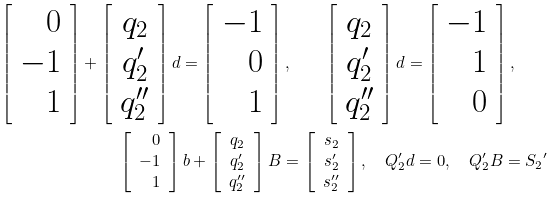Convert formula to latex. <formula><loc_0><loc_0><loc_500><loc_500>\left [ \begin{array} { r } 0 \\ - 1 \\ 1 \end{array} \right ] + \left [ \begin{array} { c } q _ { 2 } \\ q _ { 2 } ^ { \prime } \\ q _ { 2 } ^ { \prime \prime } \end{array} \right ] d = \left [ \begin{array} { r } - 1 \\ 0 \\ 1 \end{array} \right ] , \quad \left [ \begin{array} { c } q _ { 2 } \\ q _ { 2 } ^ { \prime } \\ q _ { 2 } ^ { \prime \prime } \end{array} \right ] d = \left [ \begin{array} { r } - 1 \\ 1 \\ 0 \end{array} \right ] , \quad \\ \left [ \begin{array} { r } 0 \\ - 1 \\ 1 \end{array} \right ] b + \left [ \begin{array} { c } q _ { 2 } \\ q _ { 2 } ^ { \prime } \\ q _ { 2 } ^ { \prime \prime } \end{array} \right ] B = \left [ \begin{array} { c } s _ { 2 } \\ s _ { 2 } ^ { \prime } \\ s _ { 2 } ^ { \prime \prime } \end{array} \right ] , \quad Q _ { 2 } ^ { \prime } d = 0 , \quad Q _ { 2 } ^ { \prime } B = { S _ { 2 } } ^ { \prime }</formula> 